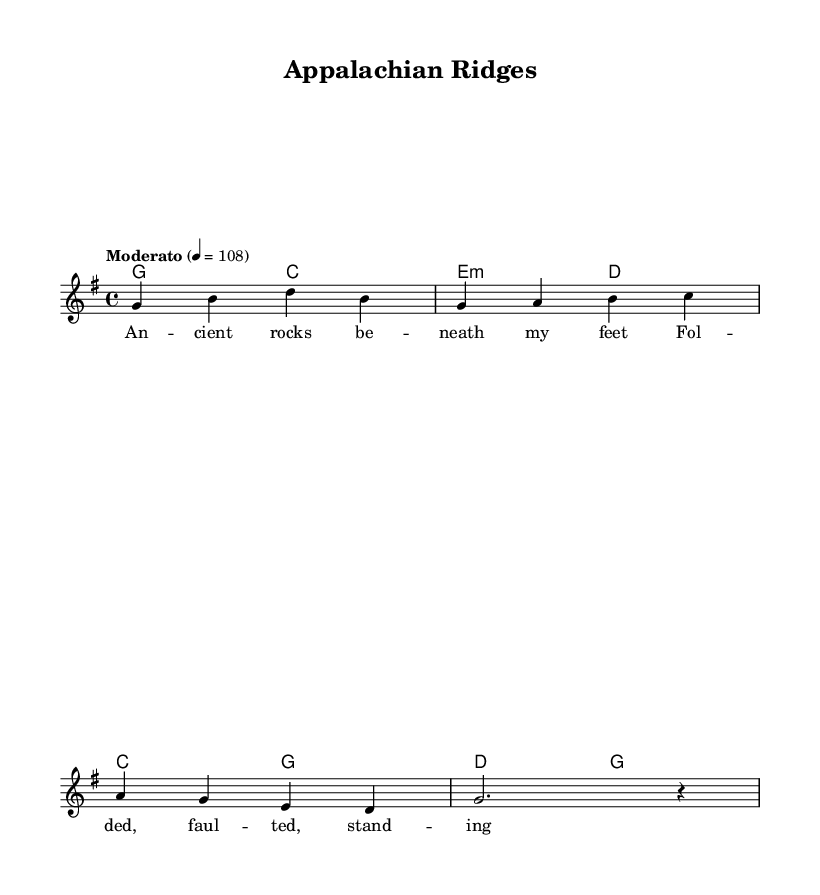What is the key signature of this music? The key signature is G major, which has one sharp (F#). You can identify the key signature by looking at the first few measures where G major is indicated at the beginning of the piece.
Answer: G major What is the time signature of this music? The time signature is 4/4, meaning there are four beats in each measure and the quarter note gets one beat. This can be seen immediately after the key signature at the beginning of the score.
Answer: 4/4 What is the tempo marking for this song? The tempo marking is "Moderato" with a specific metronome marking of 108 beats per minute. This is indicated at the beginning of the piece, showing the performer's speed for the song.
Answer: Moderato 108 What is the first chord in the verse? The first chord in the verse is G major. This can be found at the beginning of the chord progression section, indicating the harmony accompanying the melody.
Answer: G major How many lines of lyrics are in the chorus? There are two lines of lyrics in the chorus. You can see this in the lyrics section where the chorus lyrics are written under the melody, and it clearly shows two distinct lines corresponding to the musical phrases.
Answer: 2 What musical form does this song use? The song uses a verse-chorus form. This is derived from the structure of the lyrics where a verse is followed by a chorus, alternating throughout the piece. This pattern is common in country rock songs.
Answer: Verse-chorus 